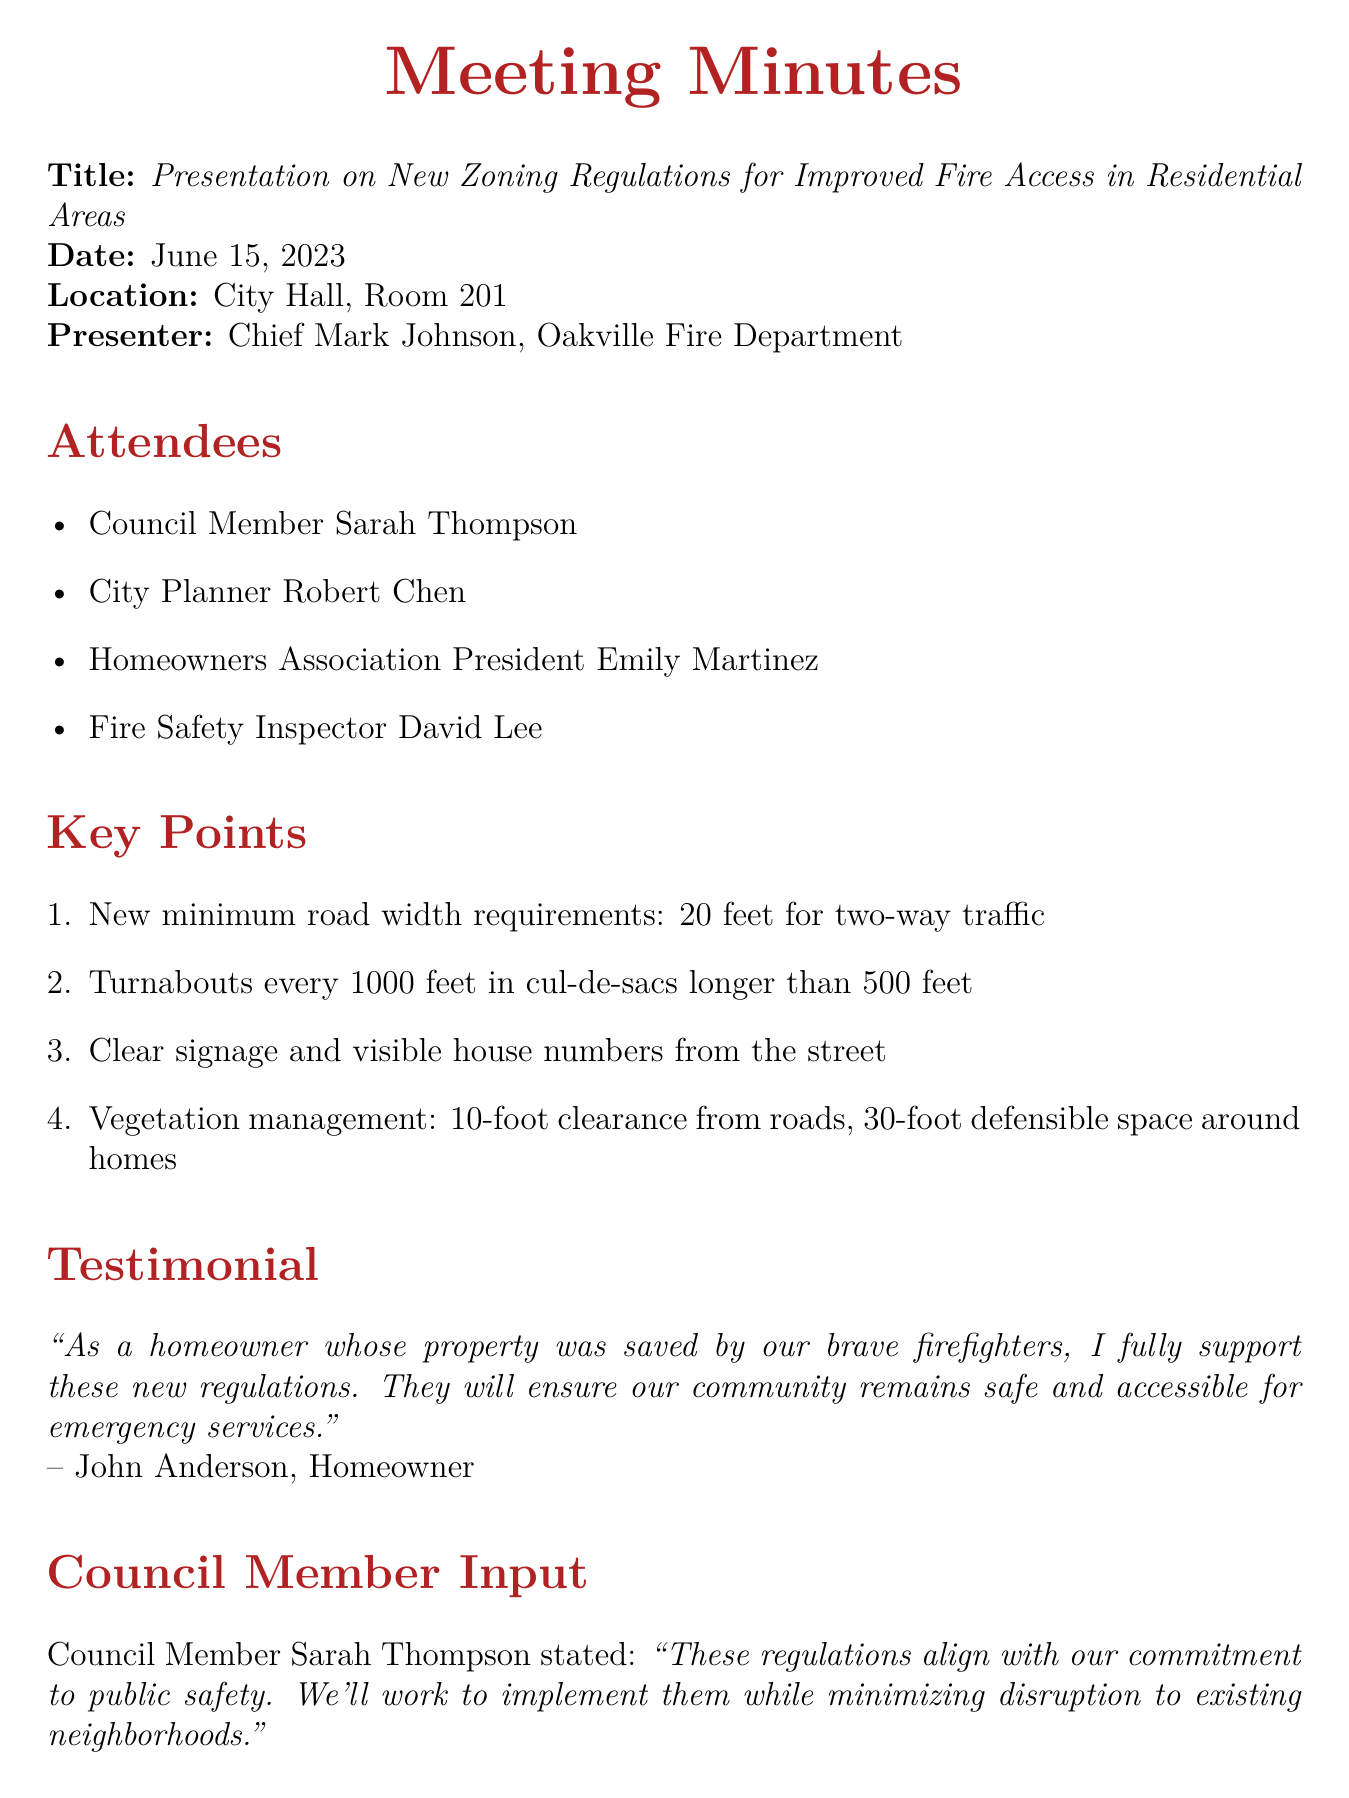What was the date of the meeting? The meeting was held on June 15, 2023, as specified at the beginning of the document.
Answer: June 15, 2023 Who presented the new zoning regulations? The presenter is mentioned in the document as Chief Mark Johnson from the Oakville Fire Department.
Answer: Chief Mark Johnson What is the minimum required road width for two-way traffic? The document states that the new minimum road width requirement is 20 feet for two-way traffic.
Answer: 20 feet When is the public hearing scheduled? The document clearly states that the public hearing is scheduled for July 10, 2023.
Answer: July 10, 2023 What is the required defensible space around homes? The key points detail that there should be a 30-foot defensible space around homes.
Answer: 30-foot What did Council Member Sarah Thompson emphasize about the regulations? The document includes her statement that these regulations align with their commitment to public safety.
Answer: Public safety What will the Fire Department conduct as part of the next steps? The next steps listed in the document indicate that the Fire Department will conduct community outreach sessions.
Answer: Community outreach sessions What is a proposed feature for cul-de-sacs longer than 500 feet? The key points mention the proposal to implement turnabouts every 1000 feet in such cul-de-sacs.
Answer: Turnabouts every 1000 feet What is the purpose of these new zoning regulations? The introduction of the meeting highlights that these regulations aim to improve fire access in residential areas.
Answer: Improve fire access 